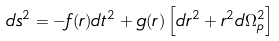Convert formula to latex. <formula><loc_0><loc_0><loc_500><loc_500>d s ^ { 2 } = - f ( r ) d t ^ { 2 } + g ( r ) \left [ d r ^ { 2 } + r ^ { 2 } d \Omega _ { p } ^ { 2 } \right ]</formula> 